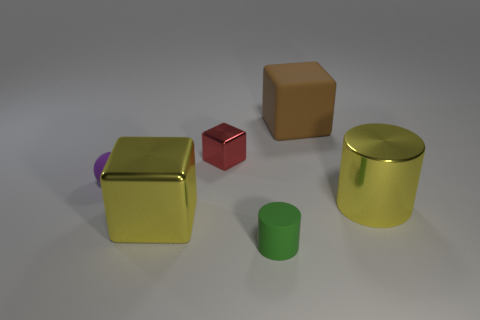Add 2 small rubber spheres. How many objects exist? 8 Subtract all spheres. How many objects are left? 5 Subtract all tiny green cylinders. Subtract all big brown objects. How many objects are left? 4 Add 2 large blocks. How many large blocks are left? 4 Add 2 brown matte things. How many brown matte things exist? 3 Subtract 0 blue blocks. How many objects are left? 6 